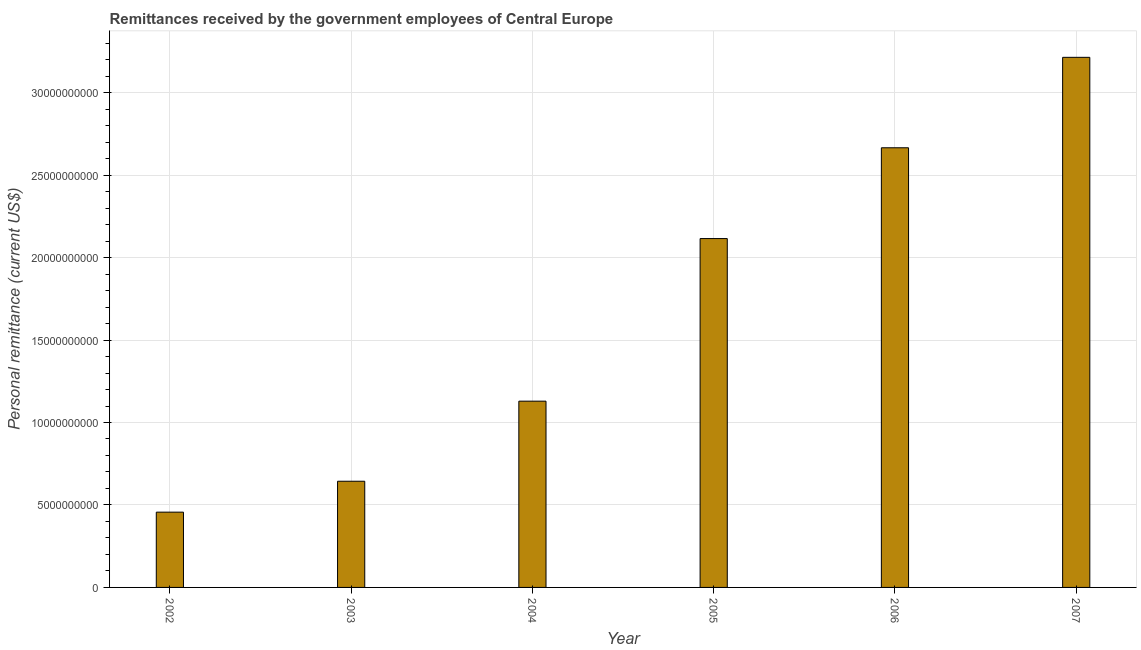Does the graph contain any zero values?
Your answer should be very brief. No. What is the title of the graph?
Provide a succinct answer. Remittances received by the government employees of Central Europe. What is the label or title of the X-axis?
Provide a short and direct response. Year. What is the label or title of the Y-axis?
Ensure brevity in your answer.  Personal remittance (current US$). What is the personal remittances in 2005?
Give a very brief answer. 2.12e+1. Across all years, what is the maximum personal remittances?
Provide a succinct answer. 3.21e+1. Across all years, what is the minimum personal remittances?
Make the answer very short. 4.56e+09. In which year was the personal remittances maximum?
Your answer should be compact. 2007. What is the sum of the personal remittances?
Provide a succinct answer. 1.02e+11. What is the difference between the personal remittances in 2005 and 2007?
Give a very brief answer. -1.10e+1. What is the average personal remittances per year?
Provide a succinct answer. 1.70e+1. What is the median personal remittances?
Your answer should be compact. 1.62e+1. Do a majority of the years between 2002 and 2005 (inclusive) have personal remittances greater than 28000000000 US$?
Your answer should be very brief. No. What is the ratio of the personal remittances in 2002 to that in 2004?
Make the answer very short. 0.4. Is the difference between the personal remittances in 2002 and 2006 greater than the difference between any two years?
Give a very brief answer. No. What is the difference between the highest and the second highest personal remittances?
Make the answer very short. 5.48e+09. Is the sum of the personal remittances in 2006 and 2007 greater than the maximum personal remittances across all years?
Provide a short and direct response. Yes. What is the difference between the highest and the lowest personal remittances?
Your response must be concise. 2.76e+1. How many bars are there?
Provide a succinct answer. 6. How many years are there in the graph?
Offer a very short reply. 6. What is the difference between two consecutive major ticks on the Y-axis?
Make the answer very short. 5.00e+09. What is the Personal remittance (current US$) of 2002?
Your response must be concise. 4.56e+09. What is the Personal remittance (current US$) in 2003?
Make the answer very short. 6.44e+09. What is the Personal remittance (current US$) of 2004?
Make the answer very short. 1.13e+1. What is the Personal remittance (current US$) in 2005?
Offer a very short reply. 2.12e+1. What is the Personal remittance (current US$) in 2006?
Provide a short and direct response. 2.67e+1. What is the Personal remittance (current US$) in 2007?
Provide a short and direct response. 3.21e+1. What is the difference between the Personal remittance (current US$) in 2002 and 2003?
Give a very brief answer. -1.87e+09. What is the difference between the Personal remittance (current US$) in 2002 and 2004?
Your answer should be compact. -6.73e+09. What is the difference between the Personal remittance (current US$) in 2002 and 2005?
Offer a terse response. -1.66e+1. What is the difference between the Personal remittance (current US$) in 2002 and 2006?
Your response must be concise. -2.21e+1. What is the difference between the Personal remittance (current US$) in 2002 and 2007?
Offer a terse response. -2.76e+1. What is the difference between the Personal remittance (current US$) in 2003 and 2004?
Your answer should be very brief. -4.86e+09. What is the difference between the Personal remittance (current US$) in 2003 and 2005?
Provide a succinct answer. -1.47e+1. What is the difference between the Personal remittance (current US$) in 2003 and 2006?
Provide a short and direct response. -2.02e+1. What is the difference between the Personal remittance (current US$) in 2003 and 2007?
Provide a short and direct response. -2.57e+1. What is the difference between the Personal remittance (current US$) in 2004 and 2005?
Offer a very short reply. -9.86e+09. What is the difference between the Personal remittance (current US$) in 2004 and 2006?
Offer a very short reply. -1.54e+1. What is the difference between the Personal remittance (current US$) in 2004 and 2007?
Keep it short and to the point. -2.08e+1. What is the difference between the Personal remittance (current US$) in 2005 and 2006?
Ensure brevity in your answer.  -5.51e+09. What is the difference between the Personal remittance (current US$) in 2005 and 2007?
Offer a terse response. -1.10e+1. What is the difference between the Personal remittance (current US$) in 2006 and 2007?
Your response must be concise. -5.48e+09. What is the ratio of the Personal remittance (current US$) in 2002 to that in 2003?
Your answer should be very brief. 0.71. What is the ratio of the Personal remittance (current US$) in 2002 to that in 2004?
Keep it short and to the point. 0.4. What is the ratio of the Personal remittance (current US$) in 2002 to that in 2005?
Offer a terse response. 0.22. What is the ratio of the Personal remittance (current US$) in 2002 to that in 2006?
Keep it short and to the point. 0.17. What is the ratio of the Personal remittance (current US$) in 2002 to that in 2007?
Your response must be concise. 0.14. What is the ratio of the Personal remittance (current US$) in 2003 to that in 2004?
Your answer should be compact. 0.57. What is the ratio of the Personal remittance (current US$) in 2003 to that in 2005?
Your answer should be very brief. 0.3. What is the ratio of the Personal remittance (current US$) in 2003 to that in 2006?
Your response must be concise. 0.24. What is the ratio of the Personal remittance (current US$) in 2003 to that in 2007?
Your response must be concise. 0.2. What is the ratio of the Personal remittance (current US$) in 2004 to that in 2005?
Offer a very short reply. 0.53. What is the ratio of the Personal remittance (current US$) in 2004 to that in 2006?
Ensure brevity in your answer.  0.42. What is the ratio of the Personal remittance (current US$) in 2004 to that in 2007?
Your answer should be compact. 0.35. What is the ratio of the Personal remittance (current US$) in 2005 to that in 2006?
Make the answer very short. 0.79. What is the ratio of the Personal remittance (current US$) in 2005 to that in 2007?
Your answer should be compact. 0.66. What is the ratio of the Personal remittance (current US$) in 2006 to that in 2007?
Your answer should be very brief. 0.83. 